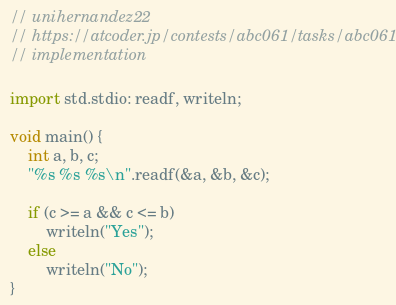Convert code to text. <code><loc_0><loc_0><loc_500><loc_500><_D_>// unihernandez22
// https://atcoder.jp/contests/abc061/tasks/abc061_a
// implementation

import std.stdio: readf, writeln;

void main() {
	int a, b, c;
	"%s %s %s\n".readf(&a, &b, &c);

	if (c >= a && c <= b)
		writeln("Yes");
	else
		writeln("No");
}
</code> 